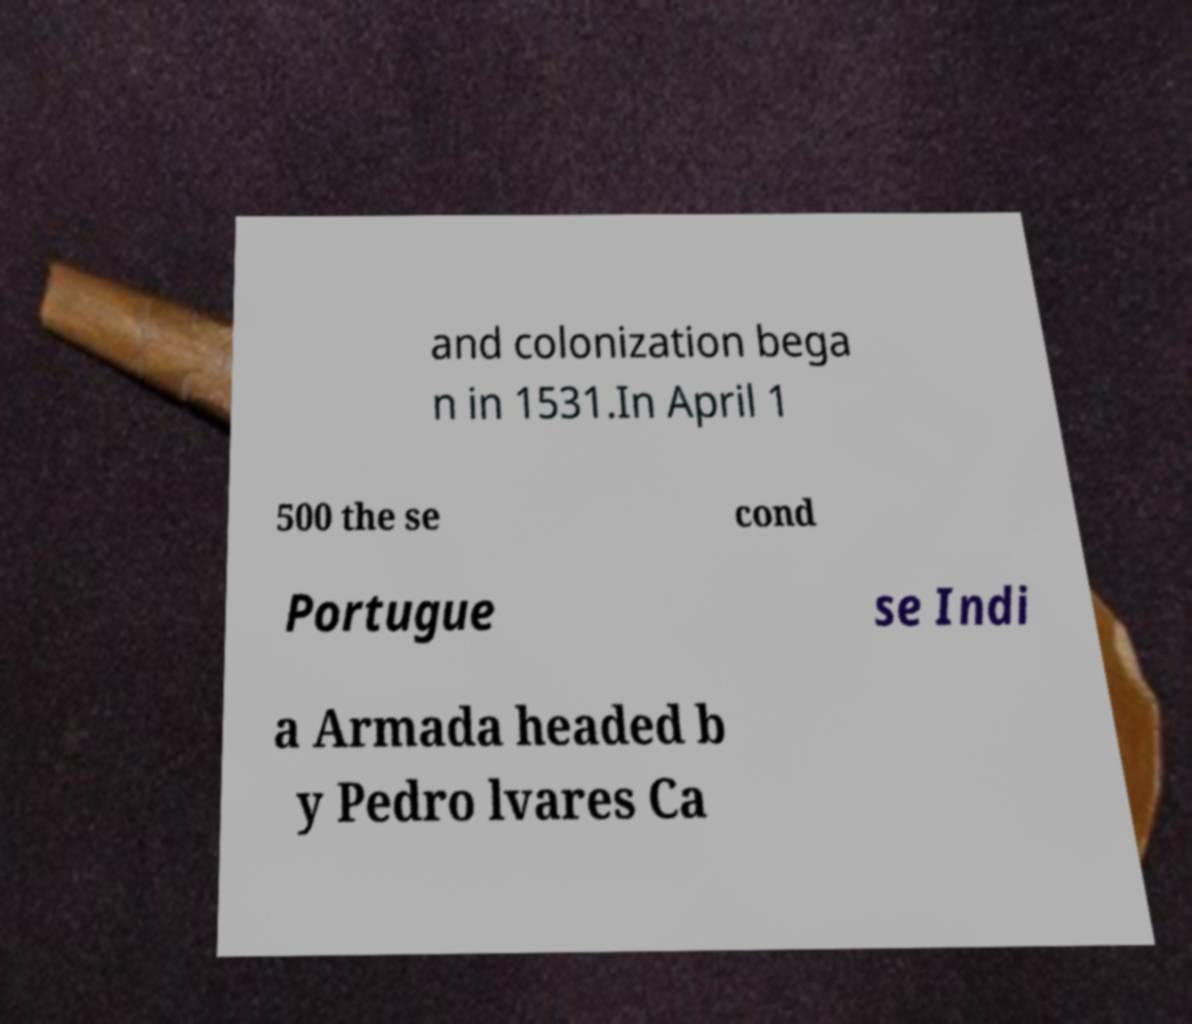Please identify and transcribe the text found in this image. and colonization bega n in 1531.In April 1 500 the se cond Portugue se Indi a Armada headed b y Pedro lvares Ca 